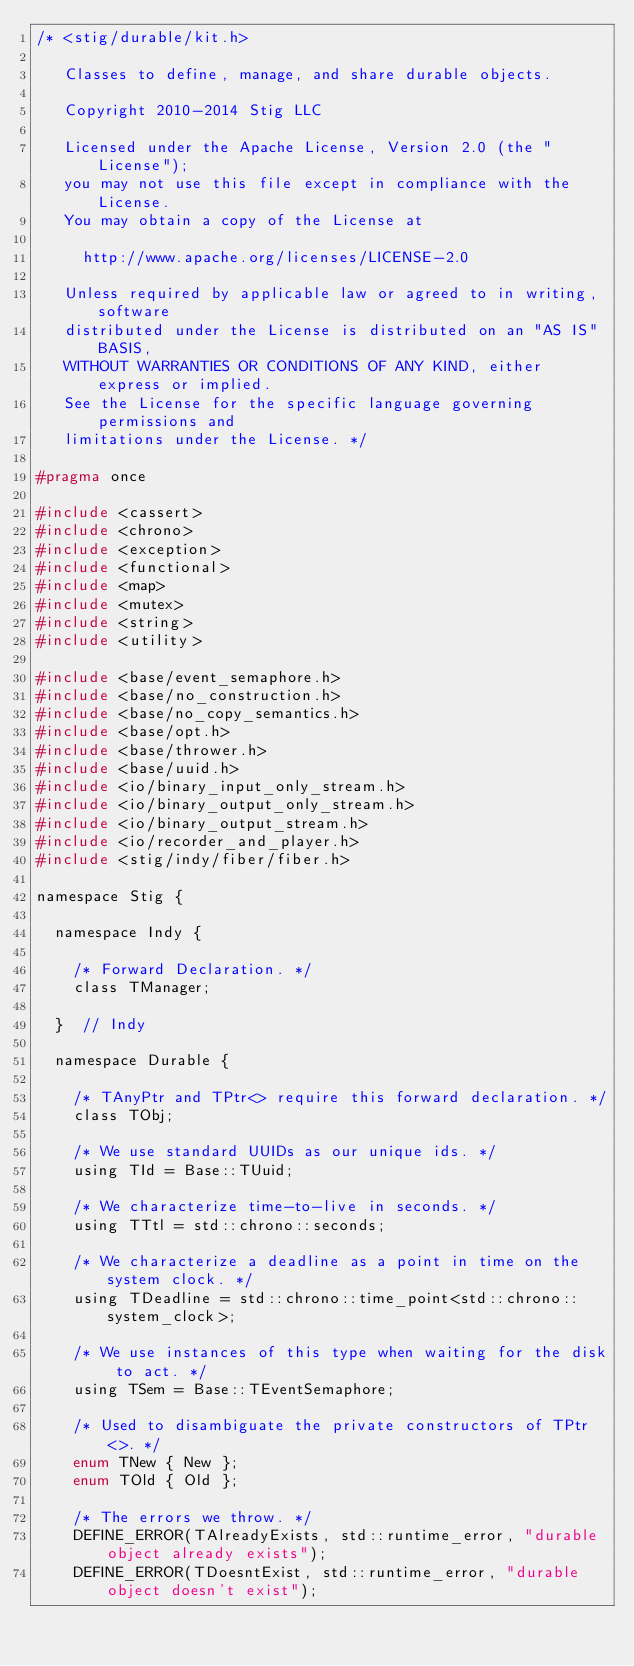<code> <loc_0><loc_0><loc_500><loc_500><_C_>/* <stig/durable/kit.h>

   Classes to define, manage, and share durable objects.

   Copyright 2010-2014 Stig LLC

   Licensed under the Apache License, Version 2.0 (the "License");
   you may not use this file except in compliance with the License.
   You may obtain a copy of the License at

     http://www.apache.org/licenses/LICENSE-2.0

   Unless required by applicable law or agreed to in writing, software
   distributed under the License is distributed on an "AS IS" BASIS,
   WITHOUT WARRANTIES OR CONDITIONS OF ANY KIND, either express or implied.
   See the License for the specific language governing permissions and
   limitations under the License. */

#pragma once

#include <cassert>
#include <chrono>
#include <exception>
#include <functional>
#include <map>
#include <mutex>
#include <string>
#include <utility>

#include <base/event_semaphore.h>
#include <base/no_construction.h>
#include <base/no_copy_semantics.h>
#include <base/opt.h>
#include <base/thrower.h>
#include <base/uuid.h>
#include <io/binary_input_only_stream.h>
#include <io/binary_output_only_stream.h>
#include <io/binary_output_stream.h>
#include <io/recorder_and_player.h>
#include <stig/indy/fiber/fiber.h>

namespace Stig {

  namespace Indy {

    /* Forward Declaration. */
    class TManager;

  }  // Indy

  namespace Durable {

    /* TAnyPtr and TPtr<> require this forward declaration. */
    class TObj;

    /* We use standard UUIDs as our unique ids. */
    using TId = Base::TUuid;

    /* We characterize time-to-live in seconds. */
    using TTtl = std::chrono::seconds;

    /* We characterize a deadline as a point in time on the system clock. */
    using TDeadline = std::chrono::time_point<std::chrono::system_clock>;

    /* We use instances of this type when waiting for the disk to act. */
    using TSem = Base::TEventSemaphore;

    /* Used to disambiguate the private constructors of TPtr<>. */
    enum TNew { New };
    enum TOld { Old };

    /* The errors we throw. */
    DEFINE_ERROR(TAlreadyExists, std::runtime_error, "durable object already exists");
    DEFINE_ERROR(TDoesntExist, std::runtime_error, "durable object doesn't exist");</code> 